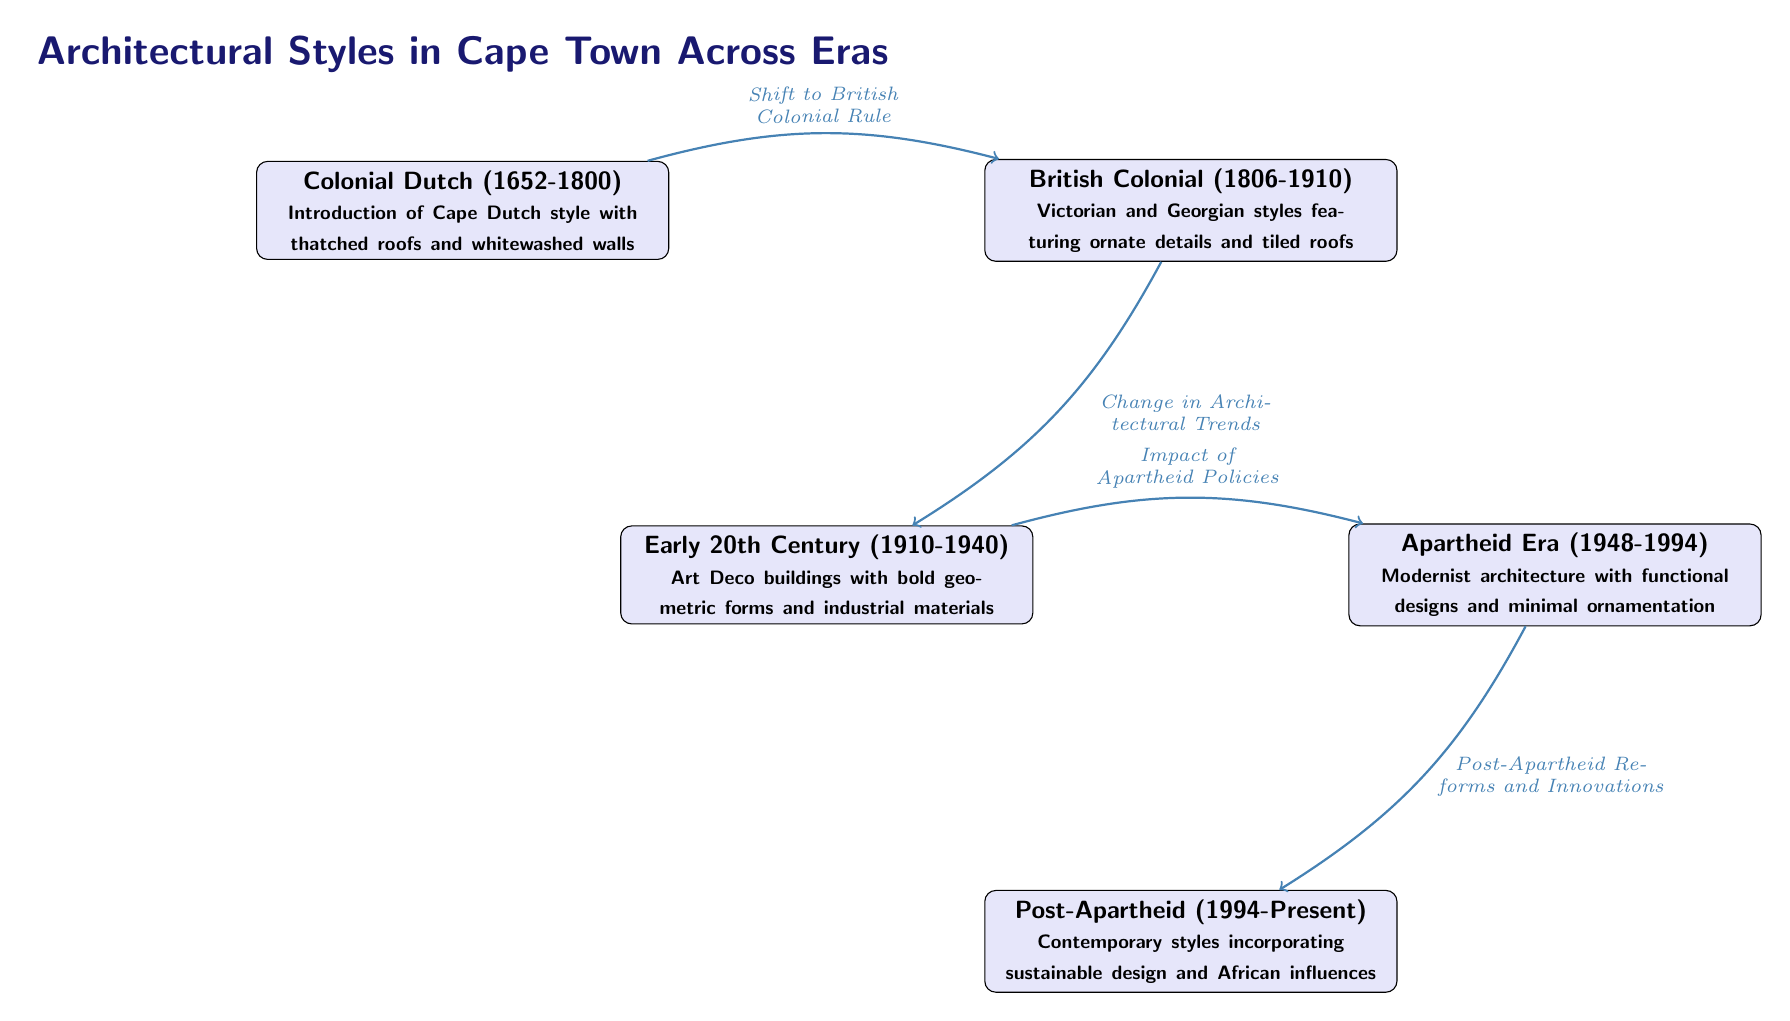What architectural style was introduced during the Colonial Dutch era? The diagram specifies that the Colonial Dutch era introduced the Cape Dutch style, characterized by thatched roofs and whitewashed walls.
Answer: Cape Dutch style What is the time period of the British Colonial style in Cape Town? According to the diagram, the British Colonial architectural style spans from 1806 to 1910.
Answer: 1806-1910 How many major architectural styles are represented in the diagram? The diagram showcases five major architectural styles aligned chronologically across different eras.
Answer: Five What architectural trend followed the Early 20th Century period? The diagram indicates that the architectural trend that followed the Early 20th Century was the Apartheid Era, which lasted from 1948 to 1994.
Answer: Apartheid Era What led to the architectural change from British Colonial to Early 20th Century? The diagram states that the change in architectural trends was the factor that led from the British Colonial style to the Early 20th Century style.
Answer: Change in Architectural Trends What are the influences noted in the Post-Apartheid architectural style? The diagram highlights that the contemporary styles of the Post-Apartheid period incorporate sustainable design and African influences.
Answer: Sustainable design and African influences What is the connection between the Early 20th Century and the Apartheid Era? According to the diagram, the impact of Apartheid policies is the reason for the transition from the Early 20th Century architecture to the Apartheid Era architecture.
Answer: Impact of Apartheid Policies What kind of architecture is depicted in the Apartheid Era? The diagram describes the style during the Apartheid Era as Modernist architecture, focusing on functional designs with minimal ornamentation.
Answer: Modernist architecture 